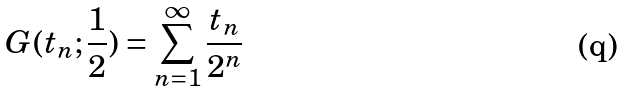Convert formula to latex. <formula><loc_0><loc_0><loc_500><loc_500>G ( t _ { n } ; \frac { 1 } { 2 } ) = \sum _ { n = 1 } ^ { \infty } \frac { t _ { n } } { 2 ^ { n } }</formula> 